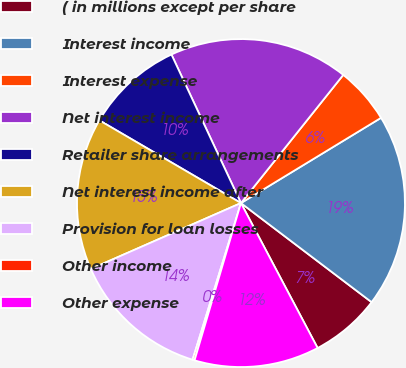Convert chart to OTSL. <chart><loc_0><loc_0><loc_500><loc_500><pie_chart><fcel>( in millions except per share<fcel>Interest income<fcel>Interest expense<fcel>Net interest income<fcel>Retailer share arrangements<fcel>Net interest income after<fcel>Provision for loan losses<fcel>Other income<fcel>Other expense<nl><fcel>6.93%<fcel>19.03%<fcel>5.58%<fcel>17.69%<fcel>9.62%<fcel>15.0%<fcel>13.65%<fcel>0.2%<fcel>12.31%<nl></chart> 